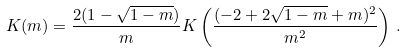<formula> <loc_0><loc_0><loc_500><loc_500>K ( m ) = \frac { 2 ( 1 - \sqrt { 1 - m } ) } { m } K \left ( \frac { ( - 2 + 2 \sqrt { 1 - m } + m ) ^ { 2 } } { m ^ { 2 } } \right ) \, .</formula> 